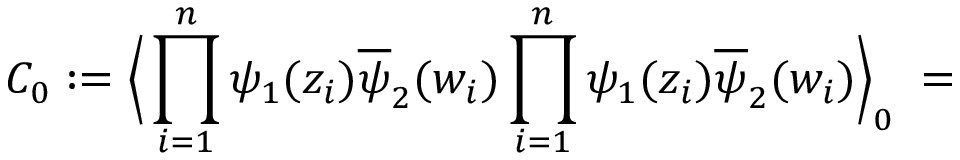Convert formula to latex. <formula><loc_0><loc_0><loc_500><loc_500>C _ { 0 } \colon = \left \langle \prod _ { i = 1 } ^ { n } \psi _ { 1 } ( z _ { i } ) \overline { \psi } _ { 2 } ( w _ { i } ) \prod _ { i = 1 } ^ { n } \psi _ { 1 } ( z _ { i } ) \overline { \psi } _ { 2 } ( w _ { i } ) \right \rangle _ { 0 } \, =</formula> 